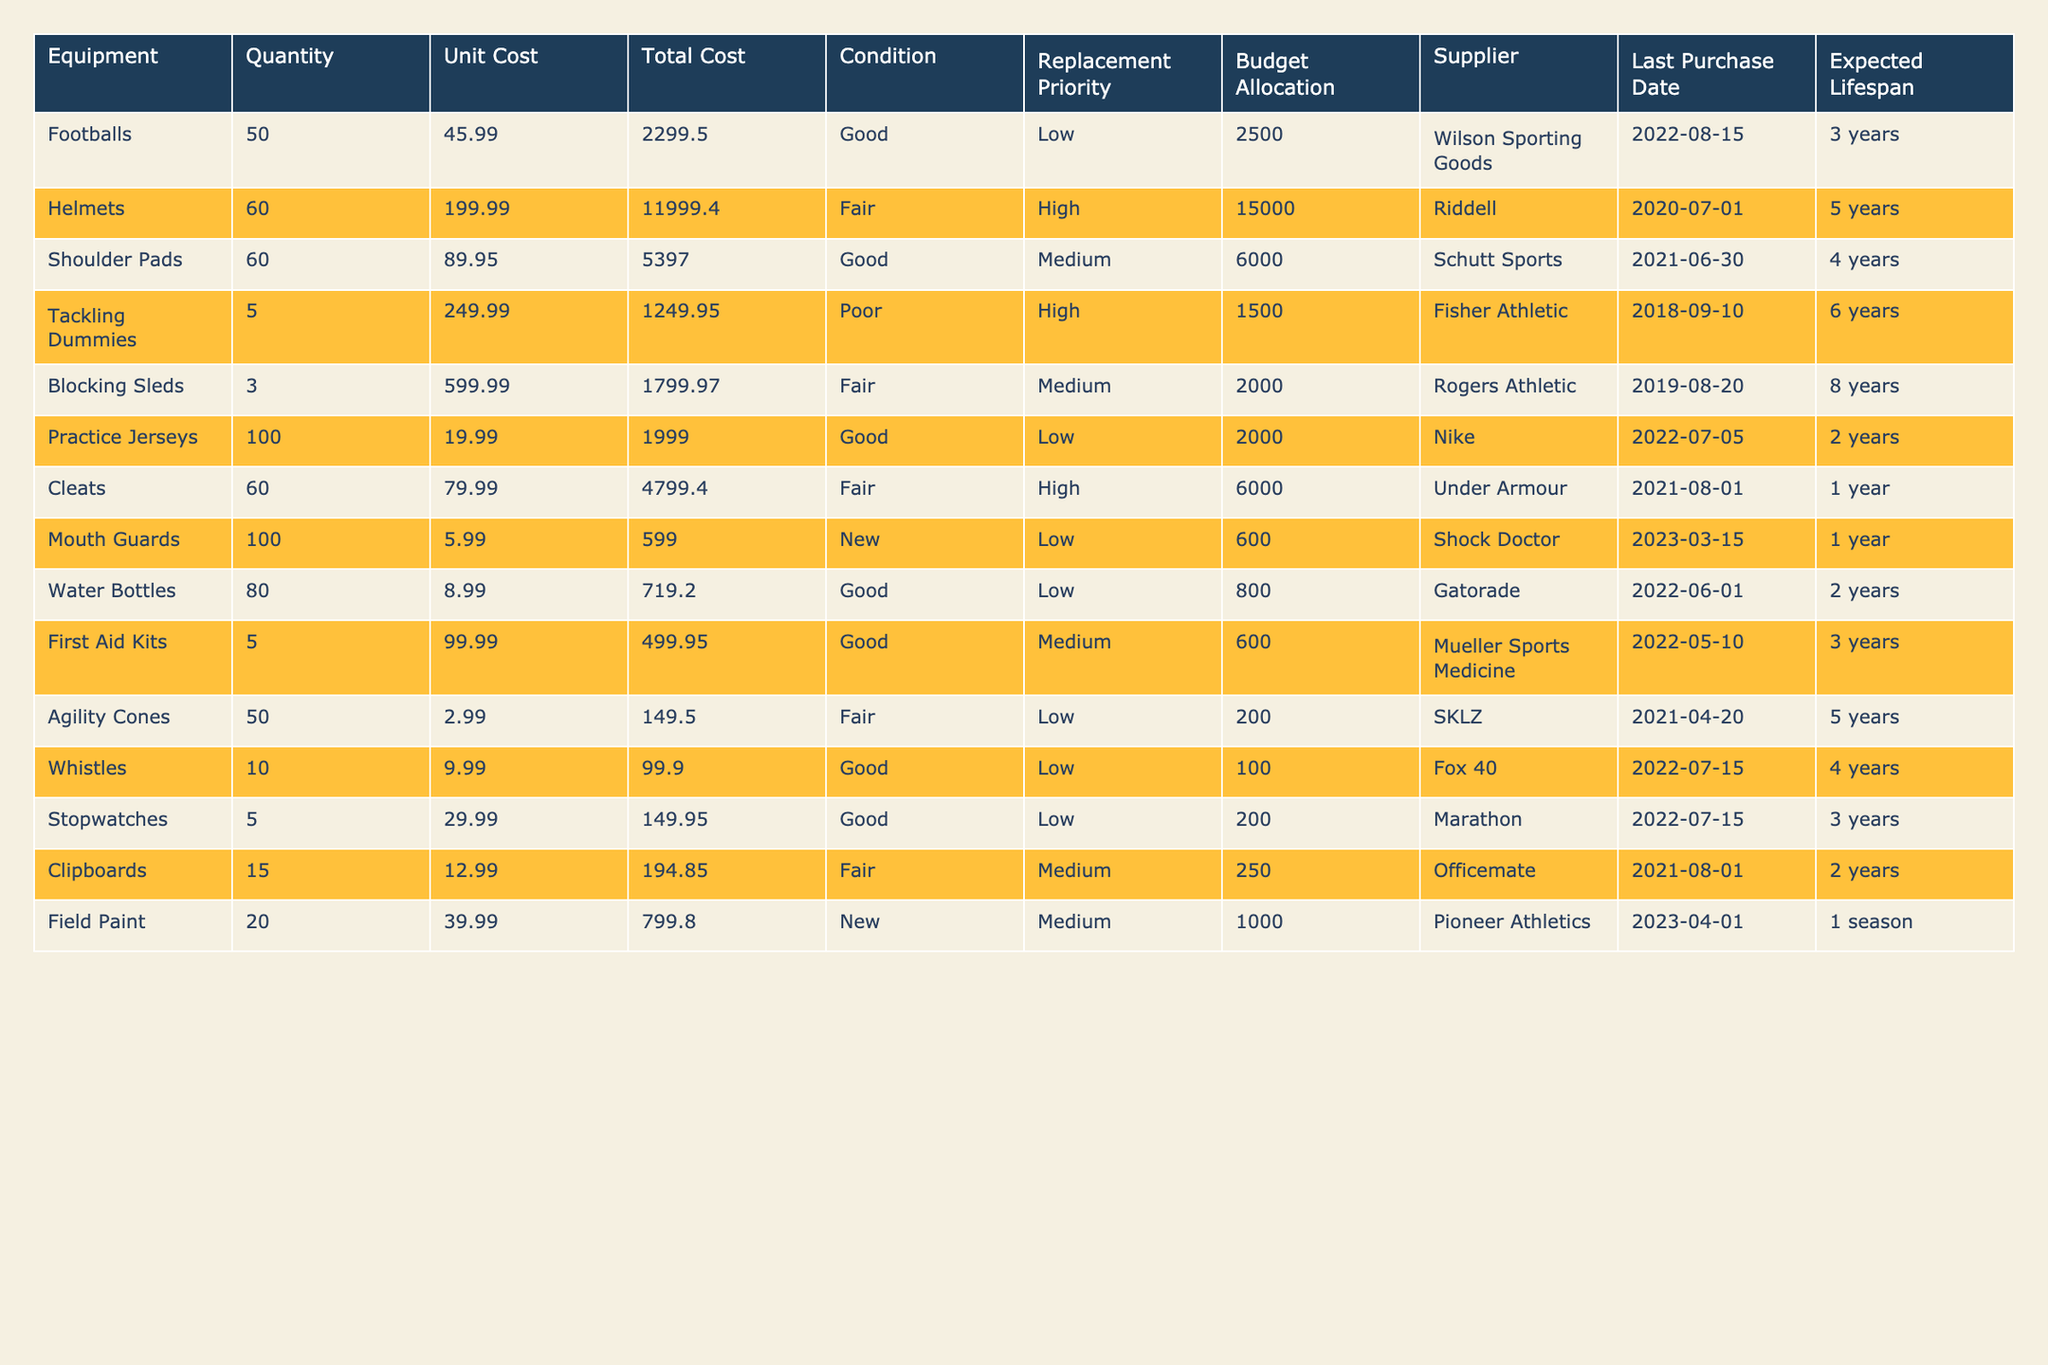What is the total cost of all helmets? The table shows that the total cost for helmets is listed as 11,999.40.
Answer: 11,999.40 How many mouth guards are in inventory? The inventory shows that there are 100 mouth guards available.
Answer: 100 What is the condition of the blocking sleds? The condition listed for blocking sleds is "Fair."
Answer: Fair What is the total budget allocation for different categories of equipment? Adding all budget allocations: 2500 (footballs) + 15000 (helmets) + 6000 (shoulder pads) + 1500 (tackling dummies) + 2000 (blocking sleds) + 2000 (practice jerseys) + 6000 (cleats) + 600 (mouth guards) + 800 (water bottles) + 600 (first aid kits) + 200 (agility cones) + 100 (whistles) + 200 (stopwatches) + 250 (clipboards) + 1000 (field paint) gives a total budget allocation of 30,000.
Answer: 30,000 How much more is allocated for helmets than for shoulder pads? The budget allocation for helmets is 15,000, and for shoulder pads, it is 6,000. The difference is 15,000 - 6,000 = 9,000.
Answer: 9,000 Which equipment has the shortest expected lifespan? The equipment with the shortest expected lifespan is "Cleats" and "Mouth Guards," both having an expected lifespan of 1 year.
Answer: Cleats and Mouth Guards Is the condition of the tackling dummies rated as poor? The condition listed for tackling dummies is "Poor," confirming the fact.
Answer: Yes What is the average unit cost of all equipment items listed? Adding the unit costs and dividing by the number of items: (45.99 + 199.99 + 89.95 + 249.99 + 599.99 + 19.99 + 79.99 + 5.99 + 8.99 + 99.99 + 2.99 + 9.99 + 29.99 + 12.99 + 39.99)/15 = 110.72.
Answer: 110.72 How many pieces of equipment have a replacement priority listed as high? The table shows that the items with high replacement priority are helmets, tackling dummies, cleats, totaling 3 items.
Answer: 3 What is the total number of equipment items that are in good condition? The items in good condition are footballs, shoulder pads, practice jerseys, water bottles, first aid kits, whistles, and stopwatches, totaling 7 items.
Answer: 7 If we replace all poor condition equipment, how much would it cost? The only item in poor condition is tackling dummies, which cost 1249.95. Thus, the total cost for replacing all poor condition equipment would be 1249.95.
Answer: 1249.95 